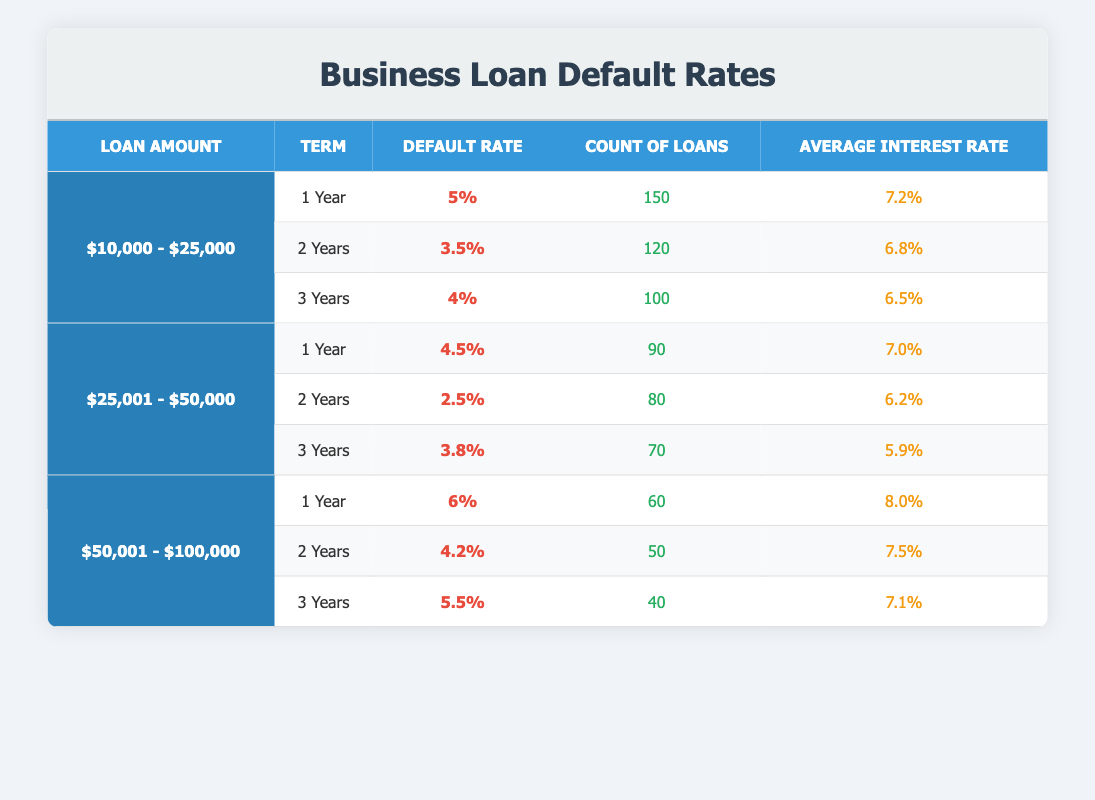What is the default rate for a loan amount of $10,000 - $25,000 with a term of 2 years? The default rate for the specified loan amount and term can be found in the table under the corresponding row. For the loan amount of $10,000 - $25,000 and a 2-year term, the default rate is 3.5%.
Answer: 3.5% How many loans were counted for the term of 1 year in the $50,001 - $100,000 loan amount category? To find this information, look at the row for the loan amount of $50,001 - $100,000 and locate the 1-year term. The count of loans for that term is listed as 60.
Answer: 60 Is the average interest rate for the $25,001 - $50,000 loan amount for a 2-year term greater than 6%? The average interest rate for the $25,001 - $50,000 loan amount with a 2-year term is 6.2%, which is greater than 6%.
Answer: Yes What is the average default rate for loans ranging from $10,000 - $25,000 across all terms? First, we need to sum the default rates across all terms for the $10,000 - $25,000 loan amount: 5% for 1 year, 3.5% for 2 years, and 4% for 3 years gives us a total of 12.5%. Then, we divide this total by 3 (the number of terms) to find the average: 12.5% / 3 = 4.17%.
Answer: 4.17% Which loan amount category has the highest default rate for a 1-year term? To find out which category has the highest default rate for 1-year terms, we review the default rates for each category: $10,000 - $25,000 has 5%, $25,001 - $50,000 has 4.5%, and $50,001 - $100,000 has 6%. The highest of these is 6% for the $50,001 - $100,000 category.
Answer: $50,001 - $100,000 What are the default rates for 3-year terms across all loan amount categories? We can retrieve the default rates listed for the 3-year terms from each loan amount category. For $10,000 - $25,000, it's 4%; for $25,001 - $50,000, it's 3.8%; and for $50,001 - $100,000, it's 5.5%. Thus, the default rates for 3-year terms across the categories are 4%, 3.8%, and 5.5%.
Answer: 4%, 3.8%, 5.5% How does the count of loans for the $25,001 - $50,000 category compare to the count of loans for the $50,001 - $100,000 category across all terms combined? The total count of loans for the $25,001 - $50,000 category is calculated as follows: 90 (1 year) + 80 (2 years) + 70 (3 years) = 240. For the $50,001 - $100,000 category: 60 (1 year) + 50 (2 years) + 40 (3 years) = 150. The $25,001 - $50,000 category has more loans by 90.
Answer: 90 What percentage of loans in the $10000 - $25000 category has a default rate lower than 4%? In the $10,000 - $25,000 category, the only term with a default rate lower than 4% is the 2-year term at 3.5%. The total number of loans in this category is 150 + 120 + 100 = 370. The count of loans with a rate lower than 4% is 120, so the percentage is (120/370) * 100 ≈ 32.43%.
Answer: 32.43% 